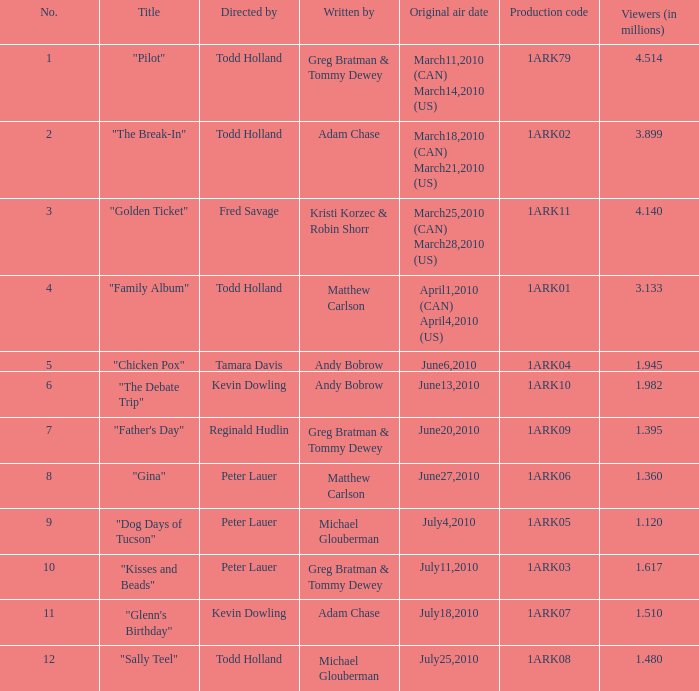What number of millions of people saw "father's day"? 1.395. 